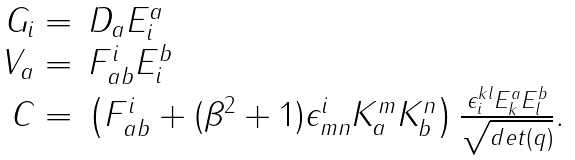<formula> <loc_0><loc_0><loc_500><loc_500>\begin{array} { r l } G _ { i } = & D _ { a } E ^ { a } _ { i } \\ V _ { a } = & F ^ { i } _ { a b } E ^ { b } _ { i } \\ C = & \left ( F ^ { i } _ { a b } + ( \beta ^ { 2 } + 1 ) \epsilon ^ { i } _ { m n } K ^ { m } _ { a } K ^ { n } _ { b } \right ) \frac { \epsilon ^ { k l } _ { i } E ^ { a } _ { k } E ^ { b } _ { l } } { \sqrt { d e t ( q ) } } . \end{array}</formula> 